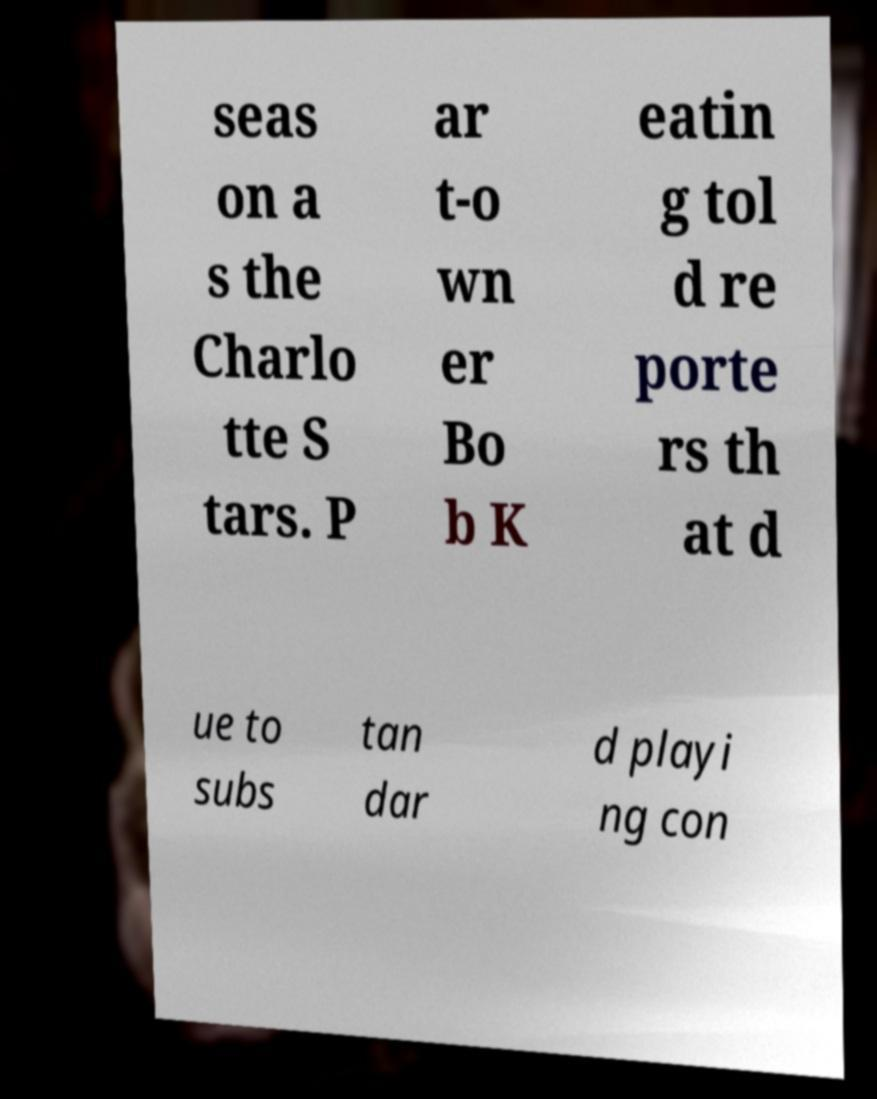For documentation purposes, I need the text within this image transcribed. Could you provide that? seas on a s the Charlo tte S tars. P ar t-o wn er Bo b K eatin g tol d re porte rs th at d ue to subs tan dar d playi ng con 